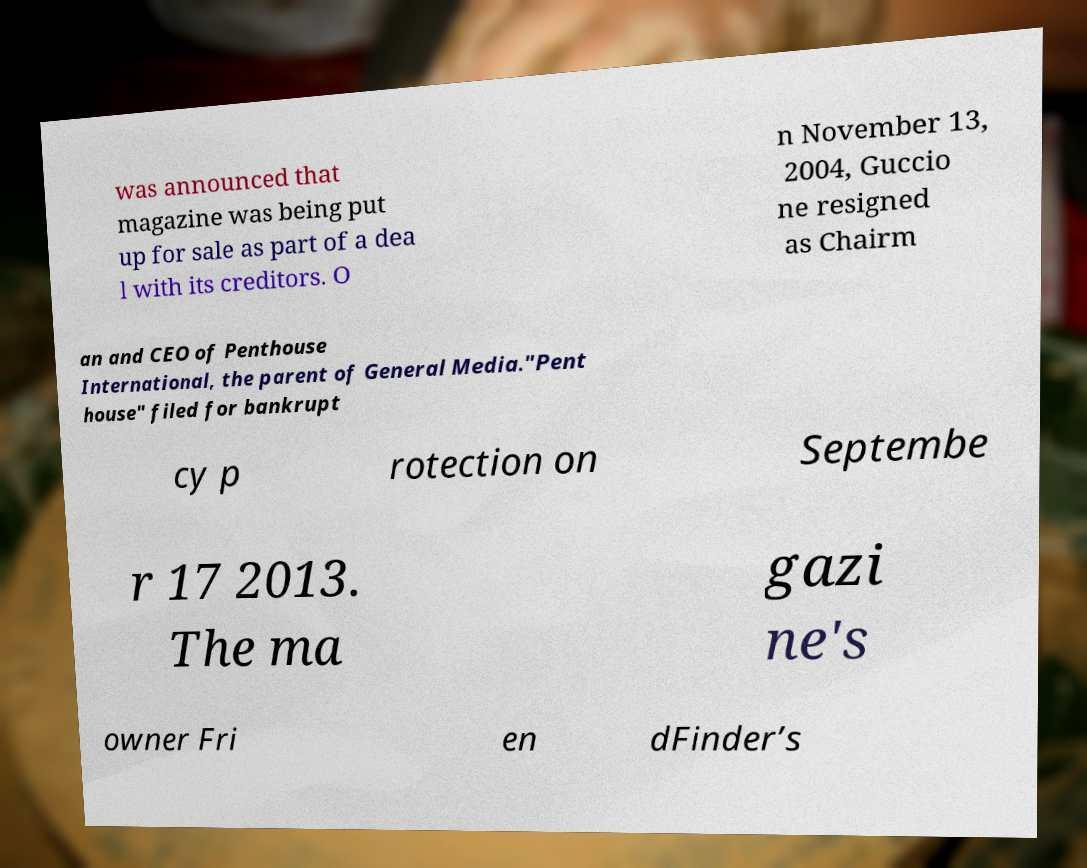Can you read and provide the text displayed in the image?This photo seems to have some interesting text. Can you extract and type it out for me? was announced that magazine was being put up for sale as part of a dea l with its creditors. O n November 13, 2004, Guccio ne resigned as Chairm an and CEO of Penthouse International, the parent of General Media."Pent house" filed for bankrupt cy p rotection on Septembe r 17 2013. The ma gazi ne's owner Fri en dFinder’s 